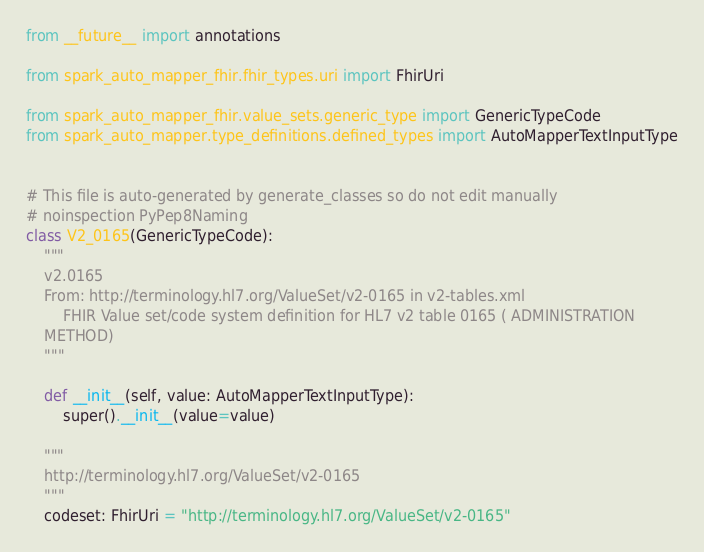<code> <loc_0><loc_0><loc_500><loc_500><_Python_>from __future__ import annotations

from spark_auto_mapper_fhir.fhir_types.uri import FhirUri

from spark_auto_mapper_fhir.value_sets.generic_type import GenericTypeCode
from spark_auto_mapper.type_definitions.defined_types import AutoMapperTextInputType


# This file is auto-generated by generate_classes so do not edit manually
# noinspection PyPep8Naming
class V2_0165(GenericTypeCode):
    """
    v2.0165
    From: http://terminology.hl7.org/ValueSet/v2-0165 in v2-tables.xml
        FHIR Value set/code system definition for HL7 v2 table 0165 ( ADMINISTRATION
    METHOD)
    """

    def __init__(self, value: AutoMapperTextInputType):
        super().__init__(value=value)

    """
    http://terminology.hl7.org/ValueSet/v2-0165
    """
    codeset: FhirUri = "http://terminology.hl7.org/ValueSet/v2-0165"
</code> 